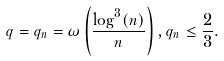Convert formula to latex. <formula><loc_0><loc_0><loc_500><loc_500>q = q _ { n } = \omega \left ( \frac { \log ^ { 3 } ( n ) } { n } \right ) , q _ { n } \leq \frac { 2 } { 3 } .</formula> 